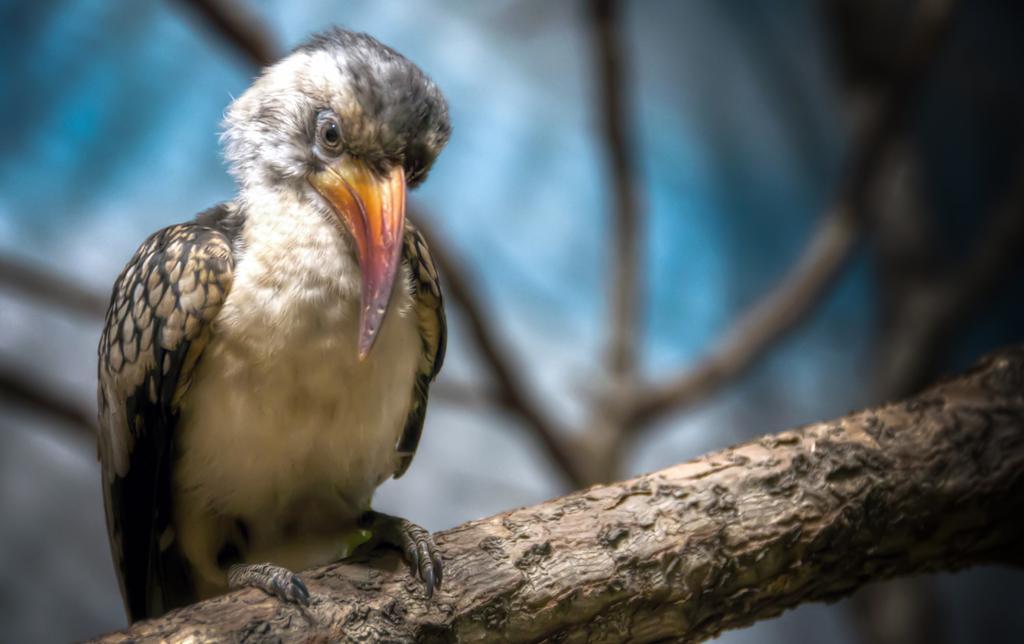Please provide a concise description of this image. In this picture we can see a bird on a branch. Background portion of the picture is blur and we can see twigs. 